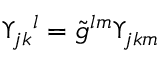Convert formula to latex. <formula><loc_0><loc_0><loc_500><loc_500>\Upsilon _ { j k ^ { l } = \tilde { g } ^ { l m } \Upsilon _ { j k m }</formula> 